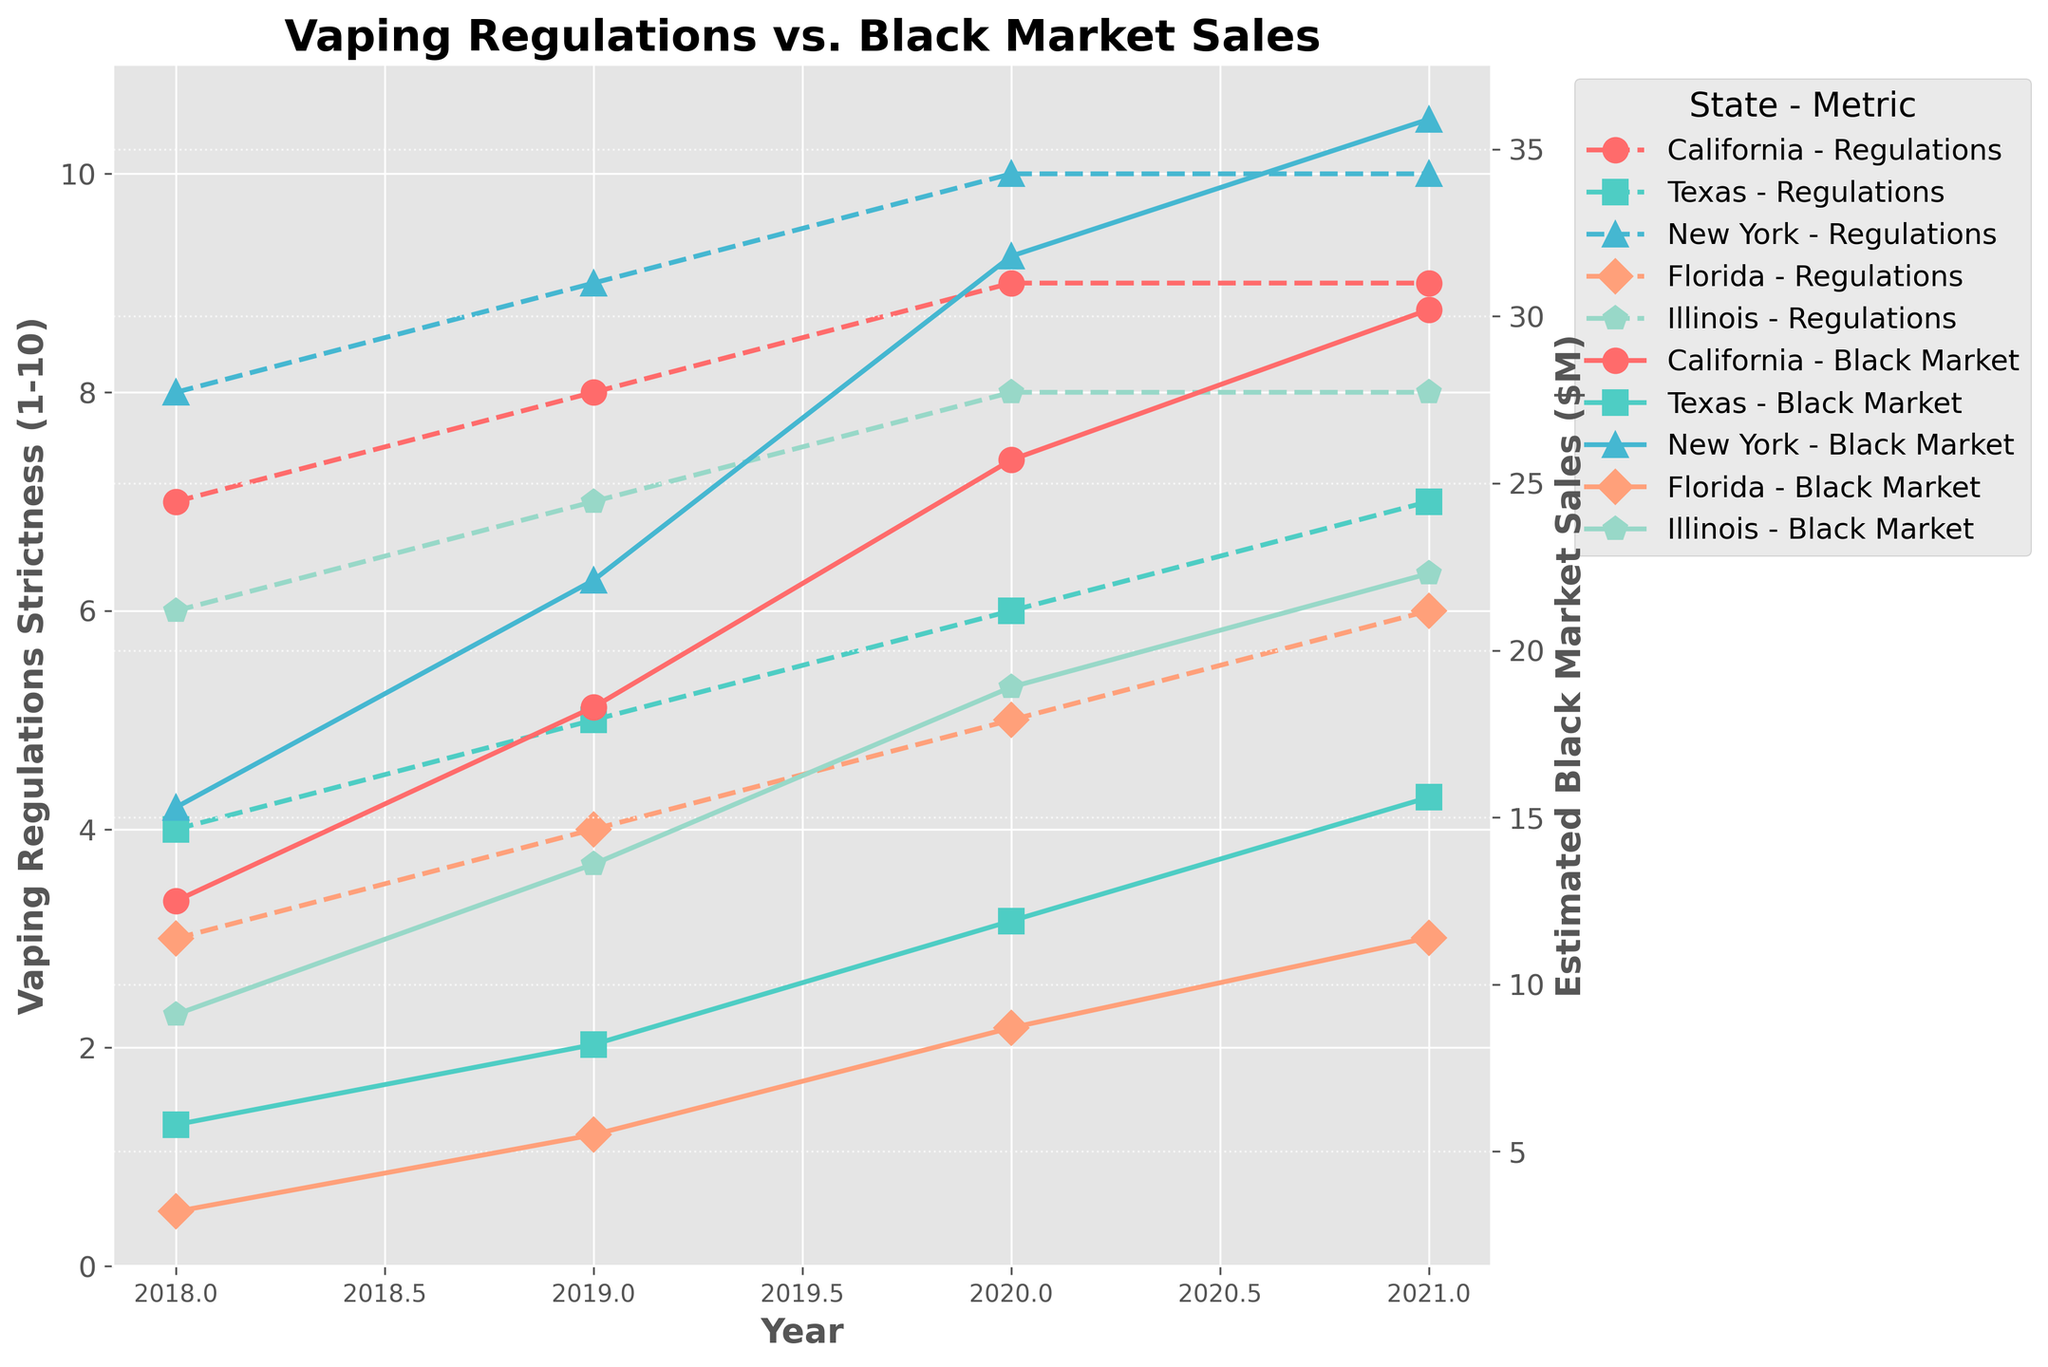Which state had the highest black market sales in 2021? To find the state with the highest black market sales in 2021, look at the estimated black market sales against the year 2021 for each state. The highest value should be identified visually.
Answer: New York How did the strictness of vaping regulations change in California from 2018 to 2021? Locate California on the plot and track the vaping regulation strictness line from 2018 to 2021. Note the change each year.
Answer: Increased What is the difference in black market sales between New York and Florida in 2020? Compare the black market sales line for New York and Florida in 2020. Subtract Florida's value from New York's value to find the difference.
Answer: 23.1 million Which state had the lowest strictness of vaping regulations in 2018, and by how much did its regulations change by 2021? Identify the initial strictness of vaping regulations for all states in 2018. Then, track the change in strictness for that state by 2021.
Answer: Florida, increased by 3 points Compare the trend of vaping regulations in California and Texas from 2018 to 2021. Which state saw a steeper increase? Track the vaping regulation lines for both California and Texas over the specified years. Calculate the overall change for each state and compare their slopes.
Answer: California What visual pattern is noted between the regulation strictness and black market sales trends for Illinois from 2018 to 2021? Observe the lines for Illinois and identify the relationship between the strictness of vaping regulations and the black market sales.
Answer: Both increased On average, how much did black market sales increase per year in Texas between 2018 and 2021? To find the average annual increase, determine the change in sales each year and find the average of these values. Calculate (8.2-5.8) + (11.9-8.2) + (15.6-11.9), then divide by 3.
Answer: 3.27 million Which year did Florida see the largest increase in black market sales, and what was the increase? Evaluate the yearly changes in Florida’s black market sales and identify the year with the largest increase.
Answer: 2020, 3.2 million In which year did Illinois have the same black market sales as Texas? Compare the black market sales values of Illinois and Texas year by year to find any matching values.
Answer: 2020 How does the color and marker for California compare to New York in the plot? Identify the colors and markers used for California and New York by visually examining the lines representing each state. California uses one color and marker, and New York uses another.
Answer: California: Red, circle; New York: Blue, triangle 